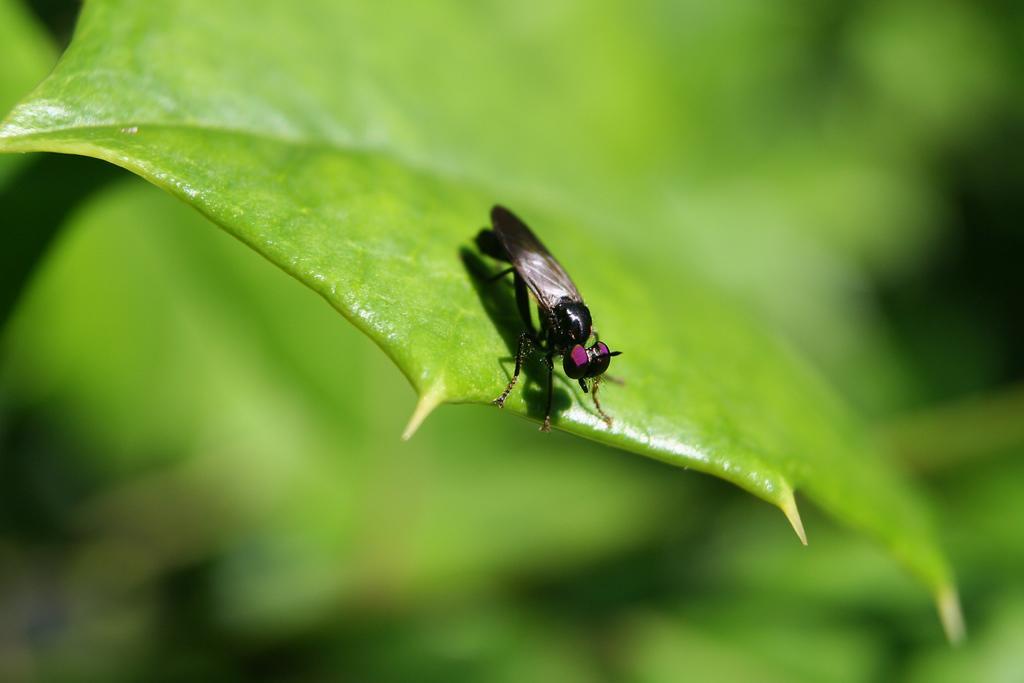In one or two sentences, can you explain what this image depicts? In this picture I can observe an insect on the leaf. This insect is in black color and the leaf is in green color. The background is blurred which is in green color. 